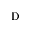Convert formula to latex. <formula><loc_0><loc_0><loc_500><loc_500>D</formula> 